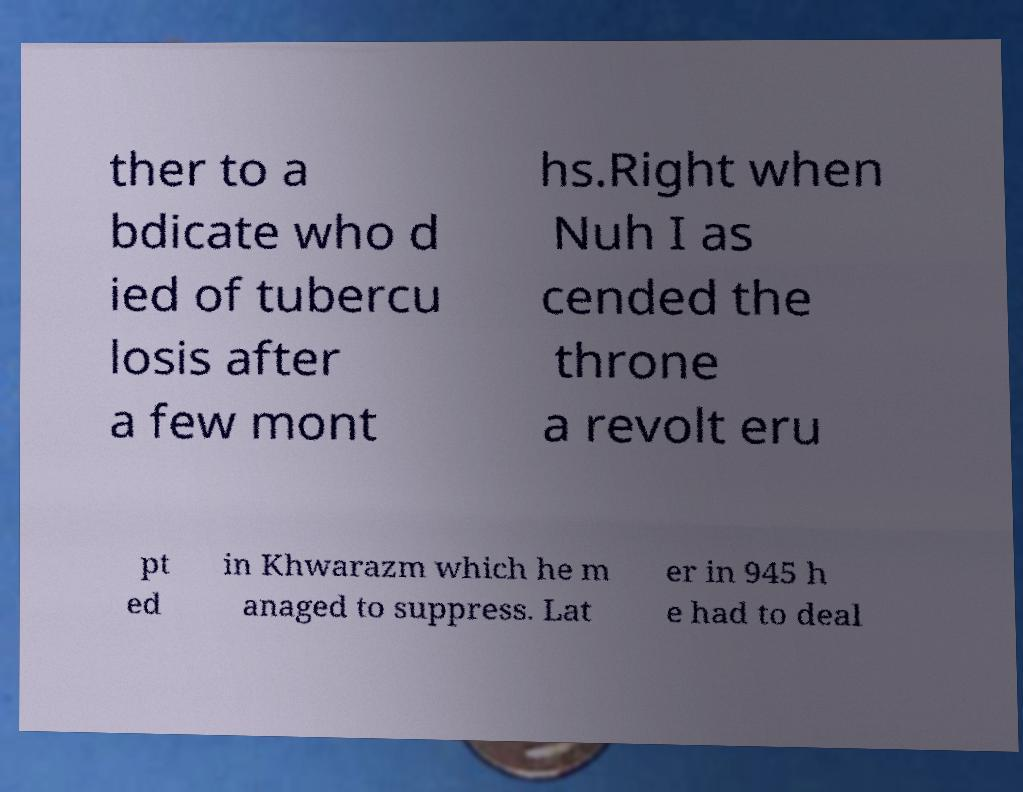Please identify and transcribe the text found in this image. ther to a bdicate who d ied of tubercu losis after a few mont hs.Right when Nuh I as cended the throne a revolt eru pt ed in Khwarazm which he m anaged to suppress. Lat er in 945 h e had to deal 